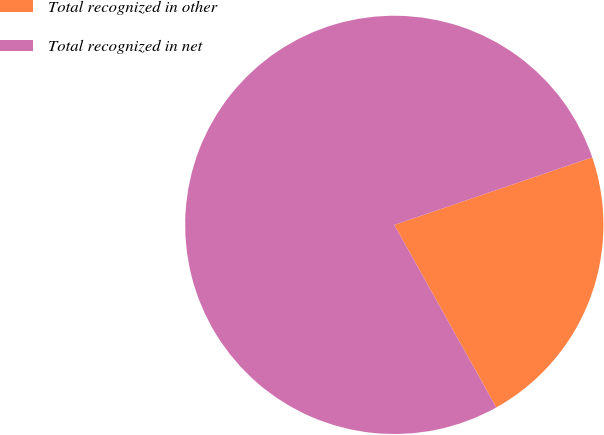<chart> <loc_0><loc_0><loc_500><loc_500><pie_chart><fcel>Total recognized in other<fcel>Total recognized in net<nl><fcel>22.13%<fcel>77.87%<nl></chart> 